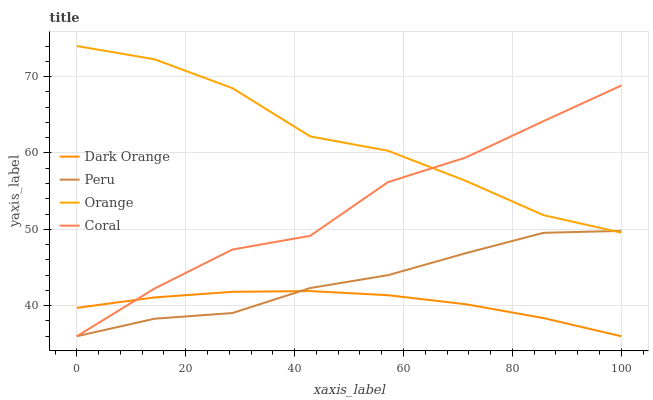Does Coral have the minimum area under the curve?
Answer yes or no. No. Does Coral have the maximum area under the curve?
Answer yes or no. No. Is Coral the smoothest?
Answer yes or no. No. Is Dark Orange the roughest?
Answer yes or no. No. Does Coral have the highest value?
Answer yes or no. No. Is Dark Orange less than Orange?
Answer yes or no. Yes. Is Orange greater than Dark Orange?
Answer yes or no. Yes. Does Dark Orange intersect Orange?
Answer yes or no. No. 